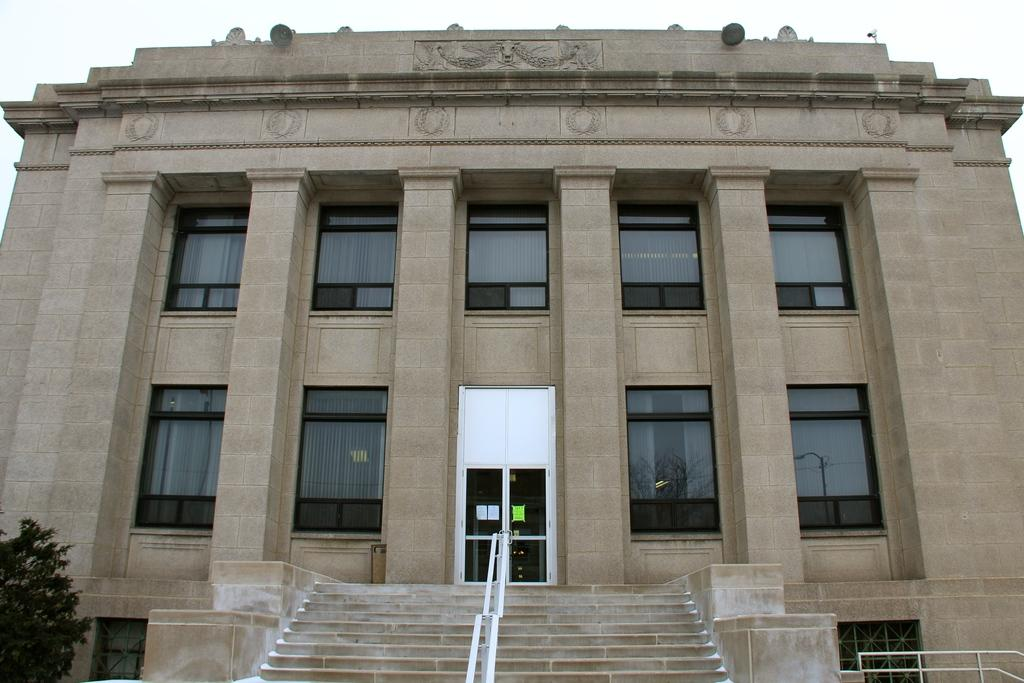What is the main structure in the middle of the image? There is a building in the middle of the image. What feature can be found inside the building? There is a staircase in the building. What type of vegetation is on the left side of the image? There is a tree on the left side of the image. What is visible at the top of the image? The sky is visible at the top of the image. What type of canvas is being used for the competition in the image? There is no canvas or competition present in the image; it features a building, a staircase, a tree, and the sky. 